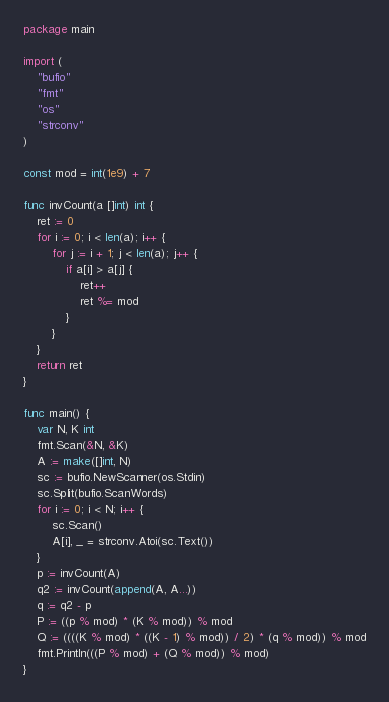Convert code to text. <code><loc_0><loc_0><loc_500><loc_500><_Go_>package main

import (
	"bufio"
	"fmt"
	"os"
	"strconv"
)

const mod = int(1e9) + 7

func invCount(a []int) int {
	ret := 0
	for i := 0; i < len(a); i++ {
		for j := i + 1; j < len(a); j++ {
			if a[i] > a[j] {
				ret++
				ret %= mod
			}
		}
	}
	return ret
}

func main() {
	var N, K int
	fmt.Scan(&N, &K)
	A := make([]int, N)
	sc := bufio.NewScanner(os.Stdin)
	sc.Split(bufio.ScanWords)
	for i := 0; i < N; i++ {
		sc.Scan()
		A[i], _ = strconv.Atoi(sc.Text())
	}
	p := invCount(A)
	q2 := invCount(append(A, A...))
	q := q2 - p
	P := ((p % mod) * (K % mod)) % mod
	Q := ((((K % mod) * ((K - 1) % mod)) / 2) * (q % mod)) % mod
	fmt.Println(((P % mod) + (Q % mod)) % mod)
}
</code> 